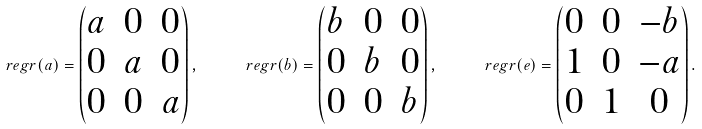Convert formula to latex. <formula><loc_0><loc_0><loc_500><loc_500>\ r e g r ( a ) = \begin{pmatrix} a & 0 & 0 \\ 0 & a & 0 \\ 0 & 0 & a \end{pmatrix} , \quad \ r e g r ( b ) = \begin{pmatrix} b & 0 & 0 \\ 0 & b & 0 \\ 0 & 0 & b \end{pmatrix} , \quad \ r e g r ( e ) = \begin{pmatrix} 0 & 0 & - b \\ 1 & 0 & - a \\ 0 & 1 & 0 \end{pmatrix} .</formula> 